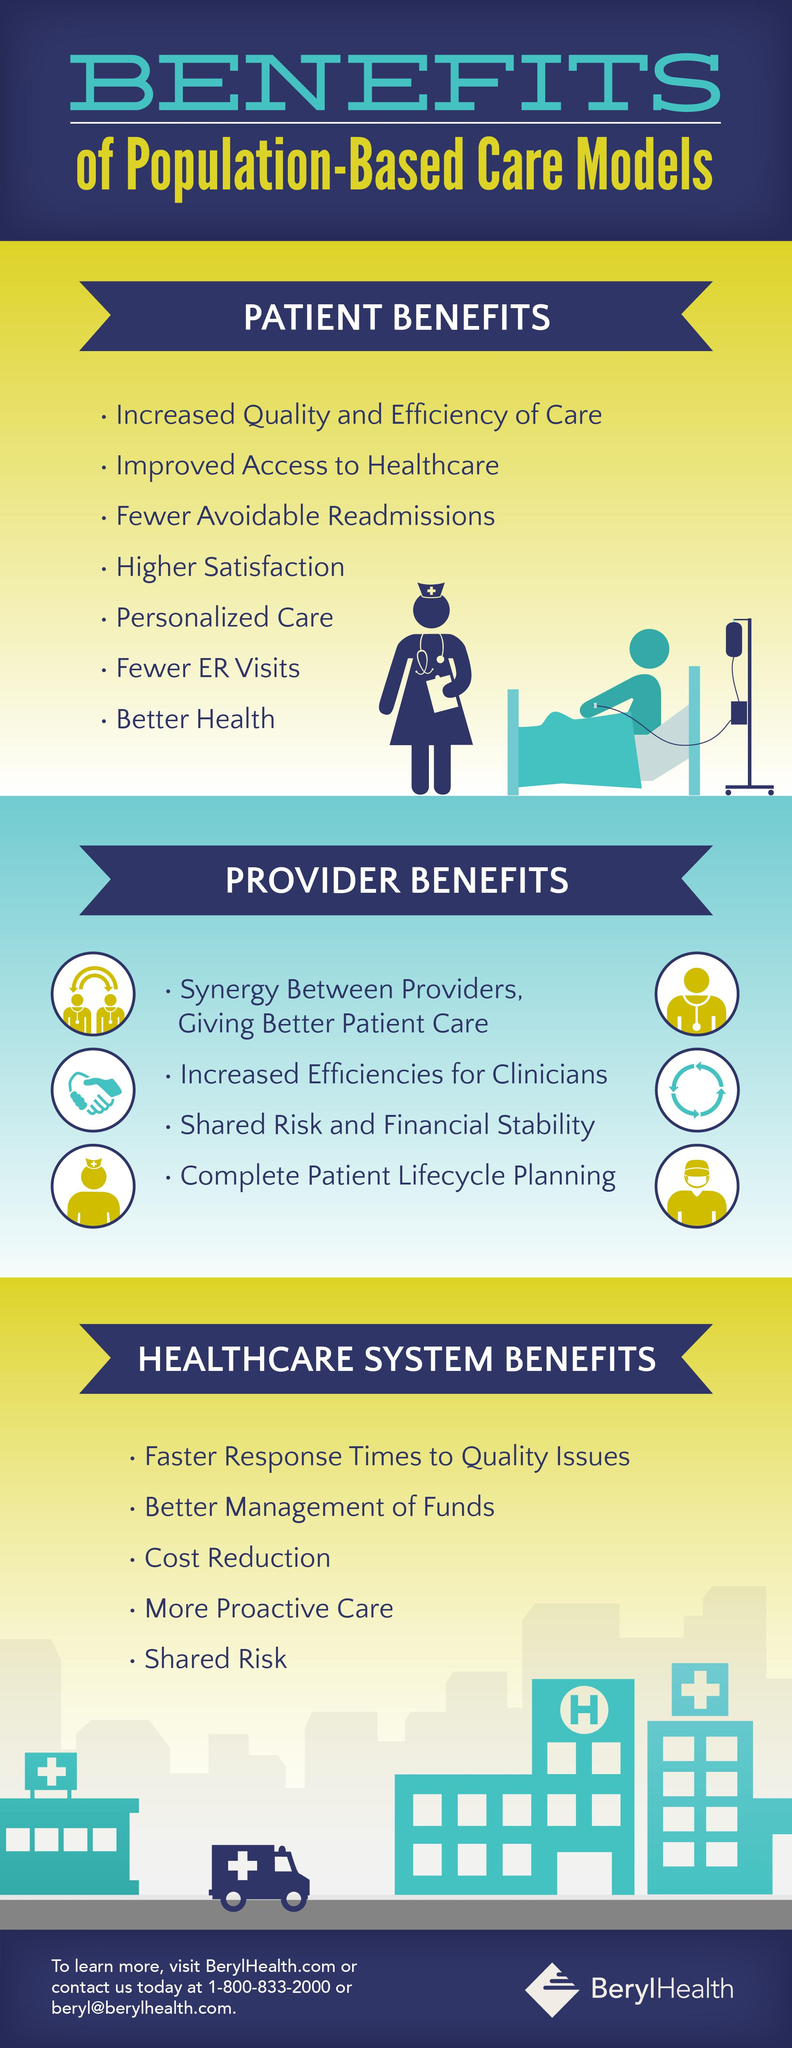List a handful of essential elements in this visual. The healthcare system provides numerous benefits to individuals, including access to affordable healthcare services and the opportunity to receive quality medical care. Seven points under the heading "Patient Benefits" have been identified. There are 4 points under the heading "Provider Benefits". 